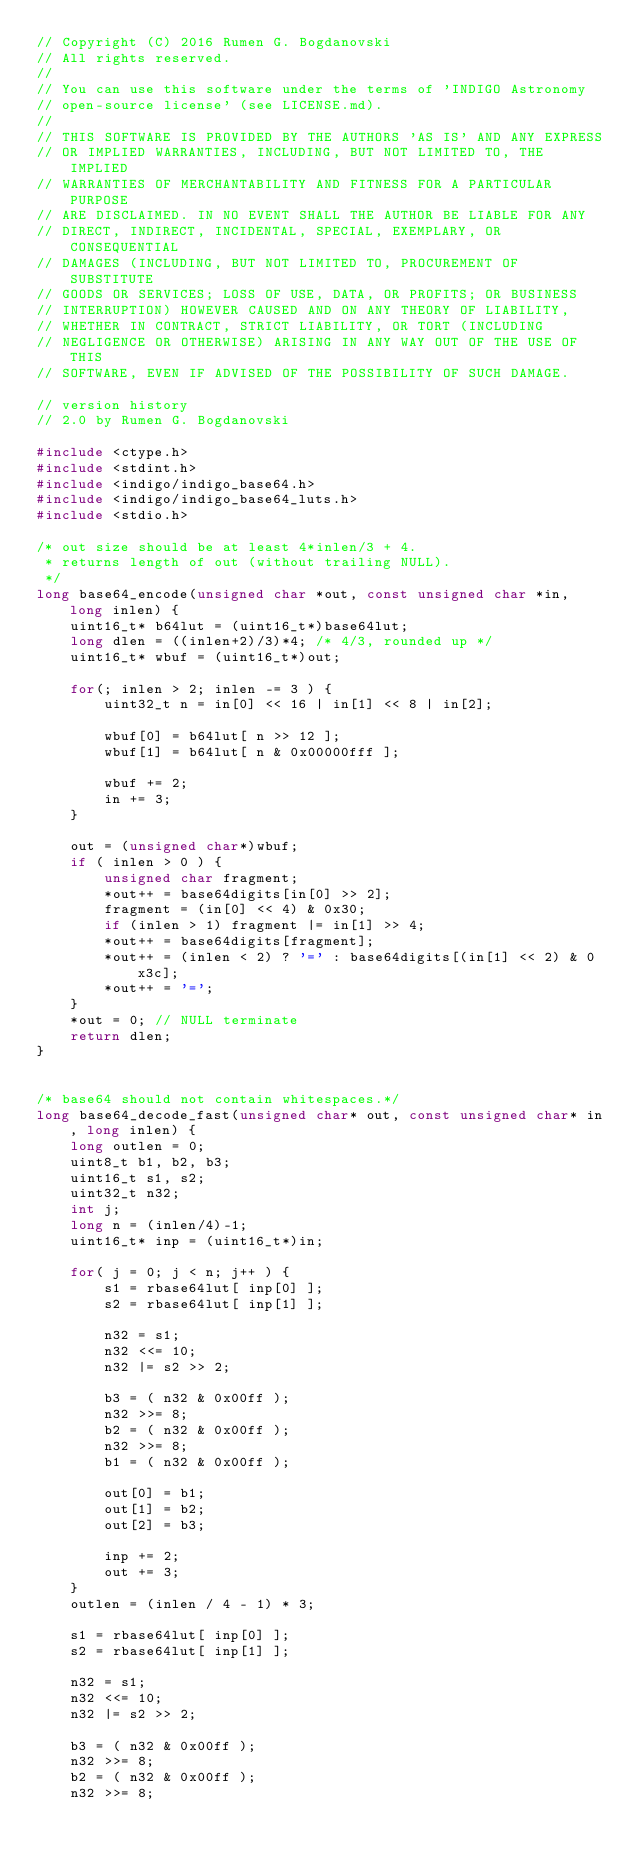<code> <loc_0><loc_0><loc_500><loc_500><_C_>// Copyright (C) 2016 Rumen G. Bogdanovski
// All rights reserved.
//
// You can use this software under the terms of 'INDIGO Astronomy
// open-source license' (see LICENSE.md).
//
// THIS SOFTWARE IS PROVIDED BY THE AUTHORS 'AS IS' AND ANY EXPRESS
// OR IMPLIED WARRANTIES, INCLUDING, BUT NOT LIMITED TO, THE IMPLIED
// WARRANTIES OF MERCHANTABILITY AND FITNESS FOR A PARTICULAR PURPOSE
// ARE DISCLAIMED. IN NO EVENT SHALL THE AUTHOR BE LIABLE FOR ANY
// DIRECT, INDIRECT, INCIDENTAL, SPECIAL, EXEMPLARY, OR CONSEQUENTIAL
// DAMAGES (INCLUDING, BUT NOT LIMITED TO, PROCUREMENT OF SUBSTITUTE
// GOODS OR SERVICES; LOSS OF USE, DATA, OR PROFITS; OR BUSINESS
// INTERRUPTION) HOWEVER CAUSED AND ON ANY THEORY OF LIABILITY,
// WHETHER IN CONTRACT, STRICT LIABILITY, OR TORT (INCLUDING
// NEGLIGENCE OR OTHERWISE) ARISING IN ANY WAY OUT OF THE USE OF THIS
// SOFTWARE, EVEN IF ADVISED OF THE POSSIBILITY OF SUCH DAMAGE.

// version history
// 2.0 by Rumen G. Bogdanovski

#include <ctype.h>
#include <stdint.h>
#include <indigo/indigo_base64.h>
#include <indigo/indigo_base64_luts.h>
#include <stdio.h>

/* out size should be at least 4*inlen/3 + 4.
 * returns length of out (without trailing NULL).
 */
long base64_encode(unsigned char *out, const unsigned char *in, long inlen) {
	uint16_t* b64lut = (uint16_t*)base64lut;
	long dlen = ((inlen+2)/3)*4; /* 4/3, rounded up */
	uint16_t* wbuf = (uint16_t*)out;

	for(; inlen > 2; inlen -= 3 ) {
		uint32_t n = in[0] << 16 | in[1] << 8 | in[2];

		wbuf[0] = b64lut[ n >> 12 ];
		wbuf[1] = b64lut[ n & 0x00000fff ];

		wbuf += 2;
		in += 3;
	}

	out = (unsigned char*)wbuf;
	if ( inlen > 0 ) {
		unsigned char fragment;
		*out++ = base64digits[in[0] >> 2];
		fragment = (in[0] << 4) & 0x30;
		if (inlen > 1) fragment |= in[1] >> 4;
		*out++ = base64digits[fragment];
		*out++ = (inlen < 2) ? '=' : base64digits[(in[1] << 2) & 0x3c];
		*out++ = '=';
	}
	*out = 0; // NULL terminate
	return dlen;
}


/* base64 should not contain whitespaces.*/
long base64_decode_fast(unsigned char* out, const unsigned char* in, long inlen) {
	long outlen = 0;
	uint8_t b1, b2, b3;
	uint16_t s1, s2;
	uint32_t n32;
	int j;
	long n = (inlen/4)-1;
	uint16_t* inp = (uint16_t*)in;

	for( j = 0; j < n; j++ ) {
		s1 = rbase64lut[ inp[0] ];
		s2 = rbase64lut[ inp[1] ];

		n32 = s1;
		n32 <<= 10;
		n32 |= s2 >> 2;

		b3 = ( n32 & 0x00ff );
		n32 >>= 8;
		b2 = ( n32 & 0x00ff );
		n32 >>= 8;
		b1 = ( n32 & 0x00ff );

		out[0] = b1;
		out[1] = b2;
		out[2] = b3;

		inp += 2;
		out += 3;
	}
	outlen = (inlen / 4 - 1) * 3;

	s1 = rbase64lut[ inp[0] ];
	s2 = rbase64lut[ inp[1] ];

	n32 = s1;
	n32 <<= 10;
	n32 |= s2 >> 2;

	b3 = ( n32 & 0x00ff );
	n32 >>= 8;
	b2 = ( n32 & 0x00ff );
	n32 >>= 8;</code> 